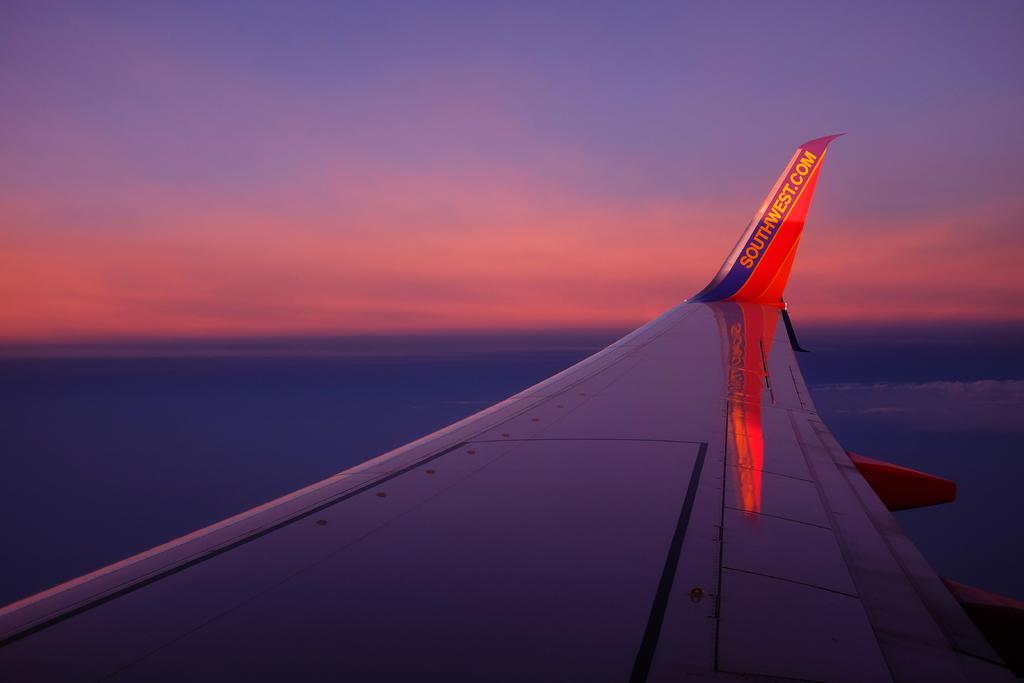<image>
Present a compact description of the photo's key features. The wing of a southwest airliner is seen as it flies through the sky at sunset. 